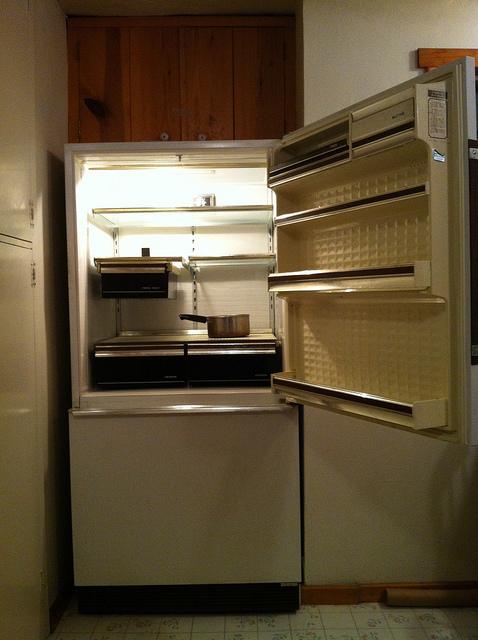What is laying on the board?
Keep it brief. Pot. Is the freezer on the top or bottom of this fridge?
Keep it brief. Bottom. Does there appear to be any consumable food inside the fridge?
Be succinct. No. Is that a stove?
Concise answer only. No. 